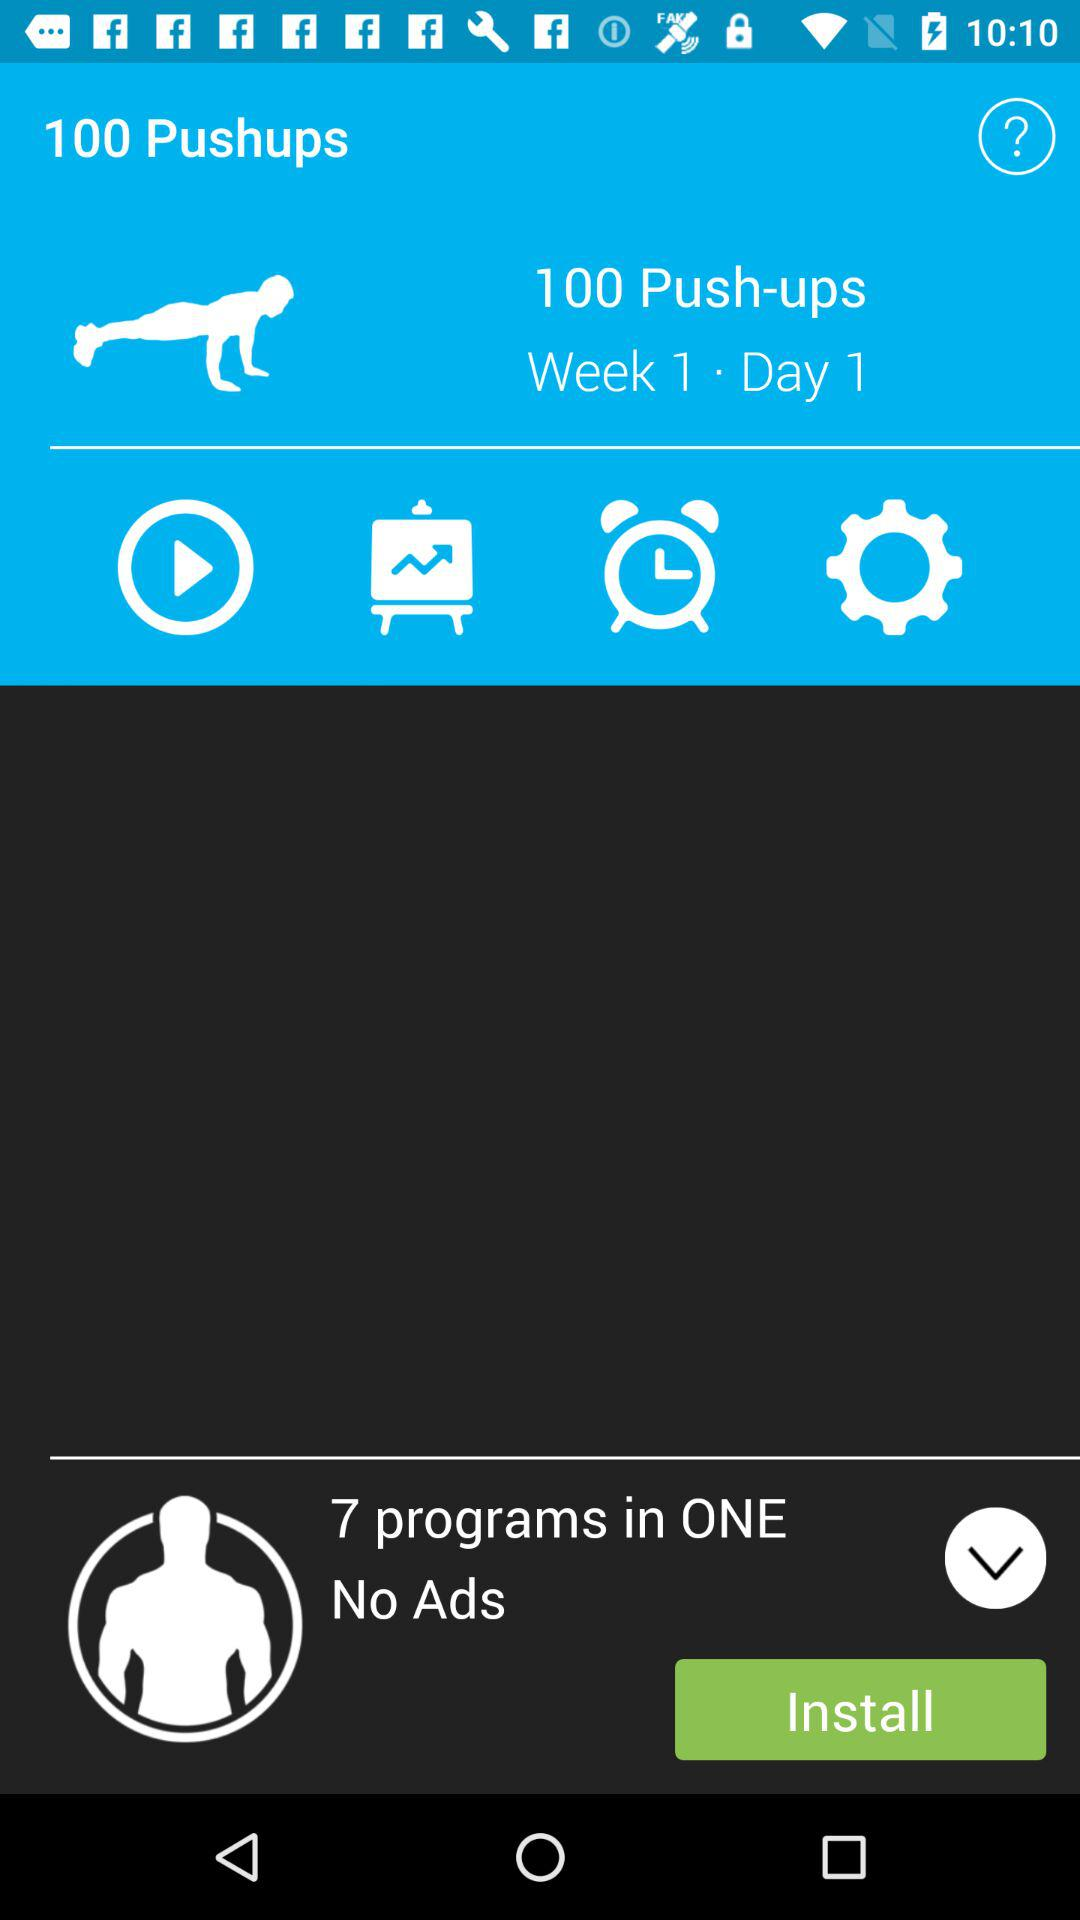How many pushups are shown here for "Week 1. Day 1"? The shown pushups are 100. 